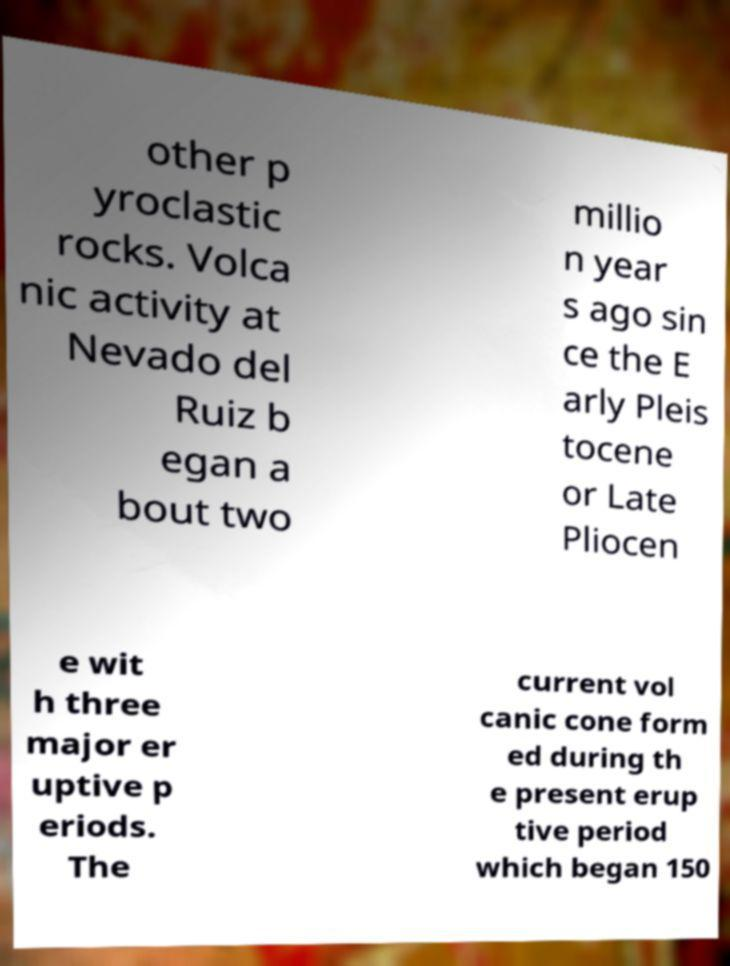Could you assist in decoding the text presented in this image and type it out clearly? other p yroclastic rocks. Volca nic activity at Nevado del Ruiz b egan a bout two millio n year s ago sin ce the E arly Pleis tocene or Late Pliocen e wit h three major er uptive p eriods. The current vol canic cone form ed during th e present erup tive period which began 150 